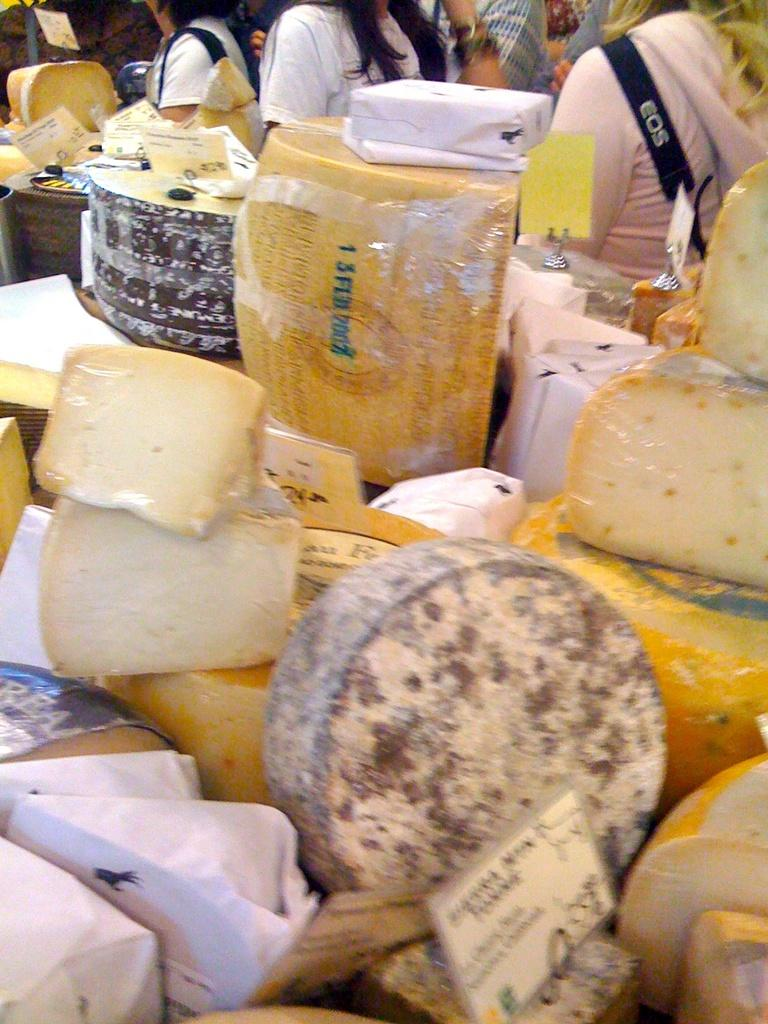What types of items can be seen in the image? There are food items and boards with text written in the image. Are there any people present in the image? Yes, there are people in the image. What is the color of the white-colored object in the image? The white-colored object in the image is white. Where is the cushion located in the image? There is no cushion present in the image. What type of home is depicted in the image? There is no home depicted in the image. 